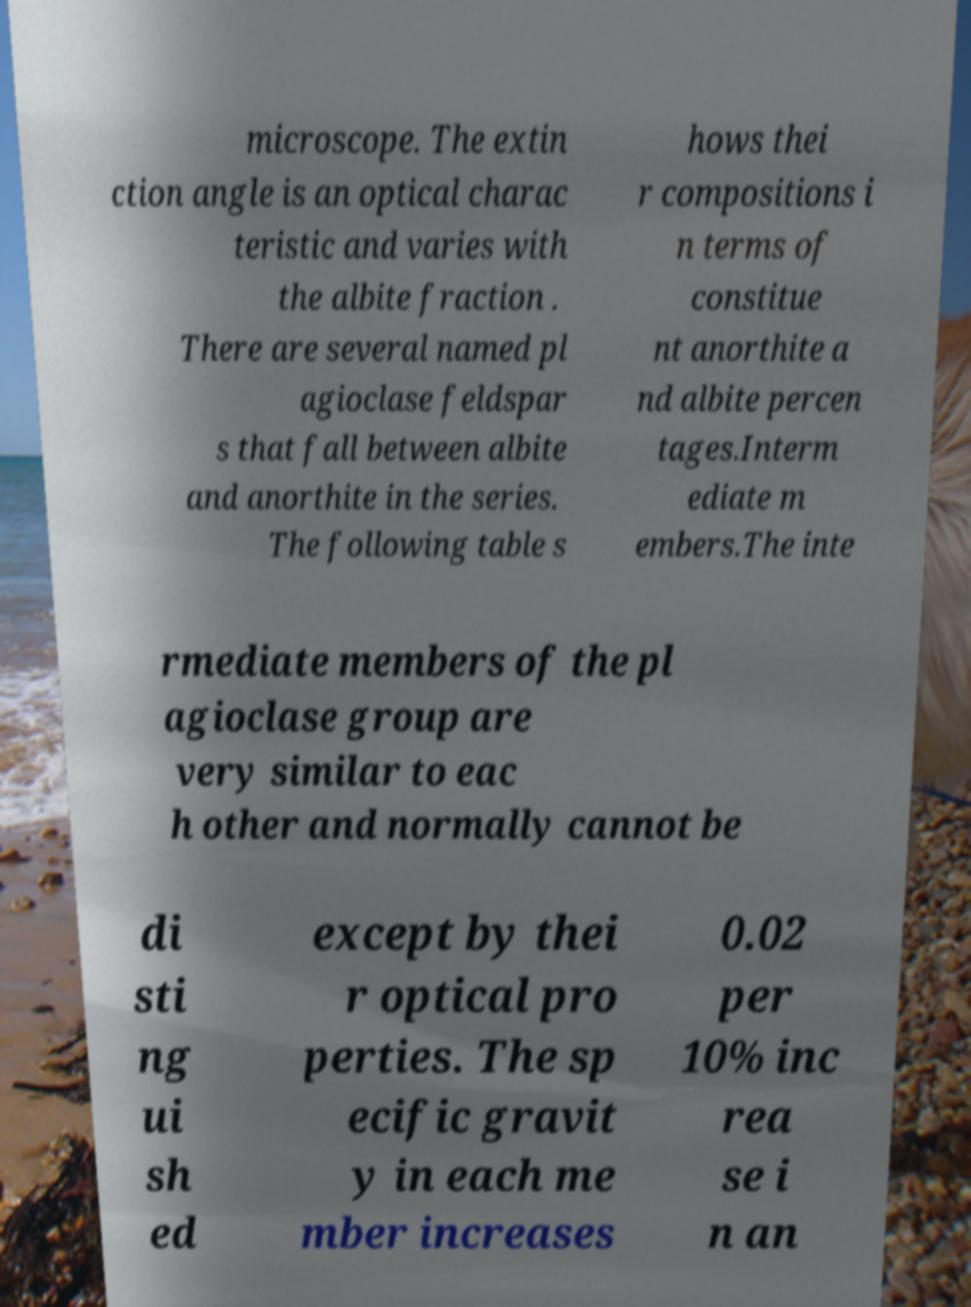Could you assist in decoding the text presented in this image and type it out clearly? microscope. The extin ction angle is an optical charac teristic and varies with the albite fraction . There are several named pl agioclase feldspar s that fall between albite and anorthite in the series. The following table s hows thei r compositions i n terms of constitue nt anorthite a nd albite percen tages.Interm ediate m embers.The inte rmediate members of the pl agioclase group are very similar to eac h other and normally cannot be di sti ng ui sh ed except by thei r optical pro perties. The sp ecific gravit y in each me mber increases 0.02 per 10% inc rea se i n an 